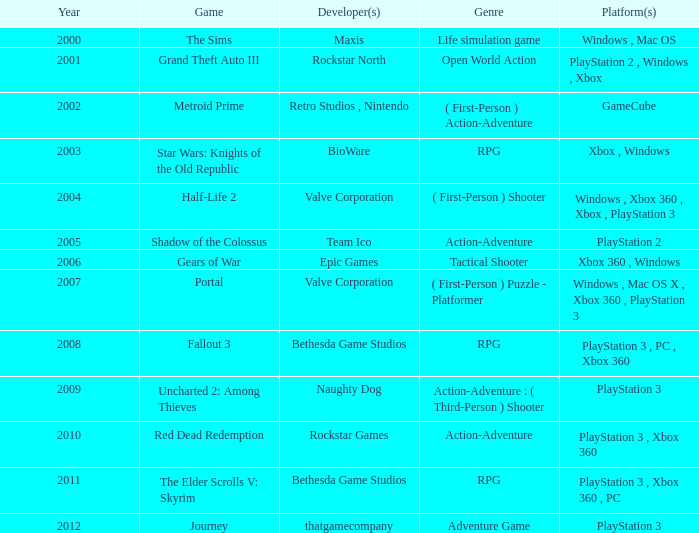What game was available in 2005? Shadow of the Colossus. 